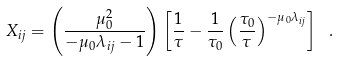Convert formula to latex. <formula><loc_0><loc_0><loc_500><loc_500>X _ { i j } = \left ( \frac { \mu _ { 0 } ^ { 2 } } { - \mu _ { 0 } \lambda _ { i j } - 1 } \right ) \left [ \frac { 1 } { \tau } - \frac { 1 } { \tau _ { 0 } } \left ( \frac { \tau _ { 0 } } { \tau } \right ) ^ { - \mu _ { 0 } \lambda _ { i j } } \right ] \ .</formula> 